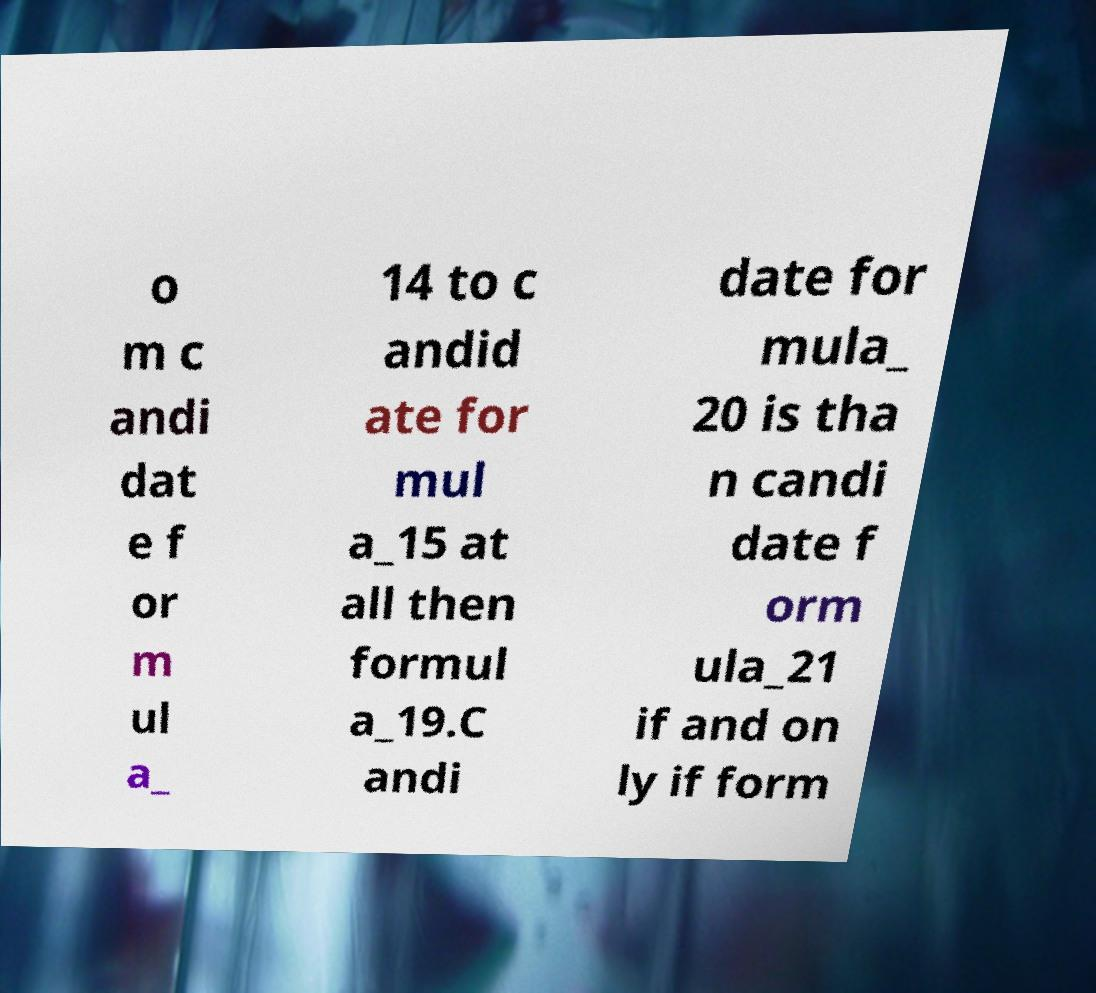Can you read and provide the text displayed in the image?This photo seems to have some interesting text. Can you extract and type it out for me? o m c andi dat e f or m ul a_ 14 to c andid ate for mul a_15 at all then formul a_19.C andi date for mula_ 20 is tha n candi date f orm ula_21 if and on ly if form 